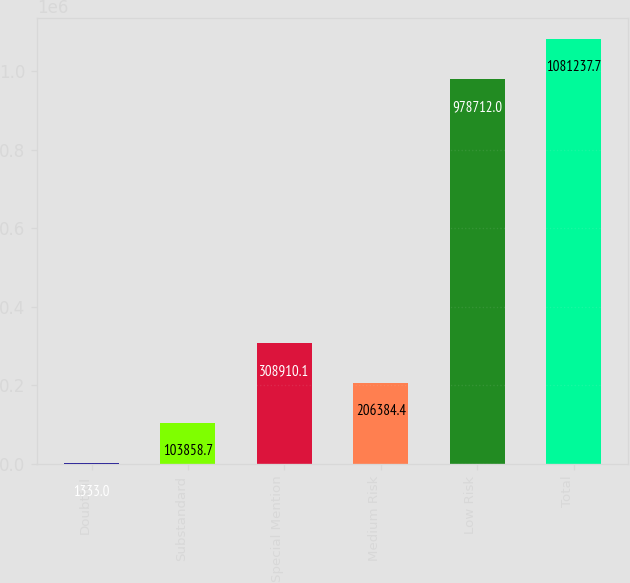Convert chart to OTSL. <chart><loc_0><loc_0><loc_500><loc_500><bar_chart><fcel>Doubtful<fcel>Substandard<fcel>Special Mention<fcel>Medium Risk<fcel>Low Risk<fcel>Total<nl><fcel>1333<fcel>103859<fcel>308910<fcel>206384<fcel>978712<fcel>1.08124e+06<nl></chart> 